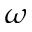Convert formula to latex. <formula><loc_0><loc_0><loc_500><loc_500>\omega</formula> 